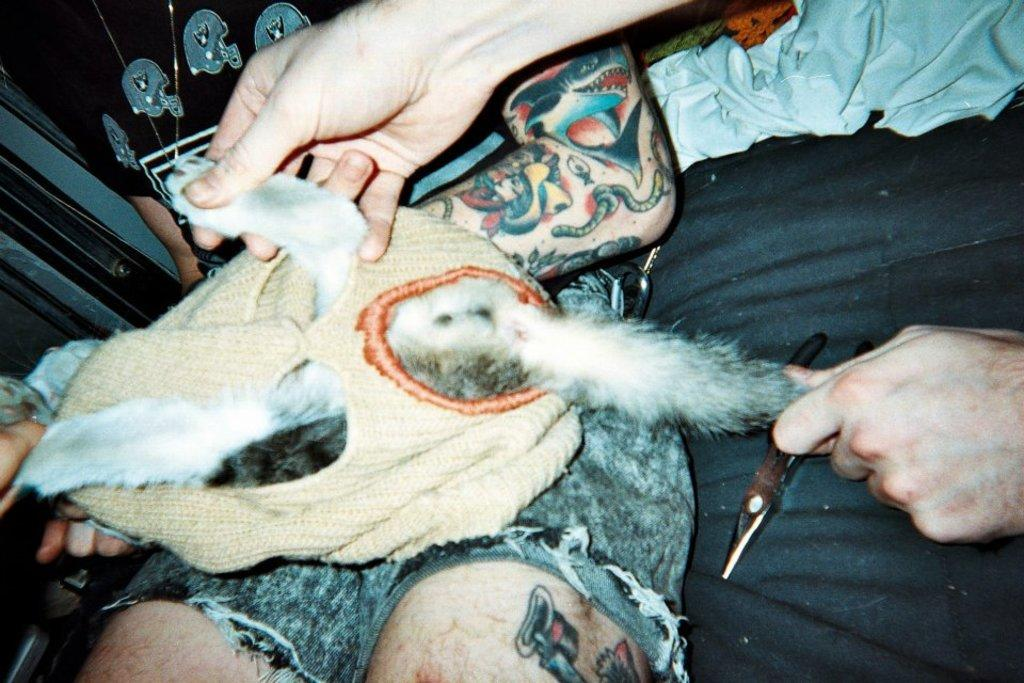What type of animal is the pet in the image? The specific type of animal cannot be determined from the provided facts. Where is the pet located in the image? The pet is on the lap of a person. How many people are in the image? There are two people in the image. What is the second person doing with the pet? The second person is holding the tail and leg of the pet. What object is on the lap of the person with the pet? There is a tool on the lap of the person with the pet. What type of protest is happening in the image? There is no protest present in the image; it features a pet on a person's lap and another person holding the pet's tail and leg. What discovery was made by the person holding the pet's leg? There is no indication of a discovery in the image; it simply shows a pet and two people interacting with it. 